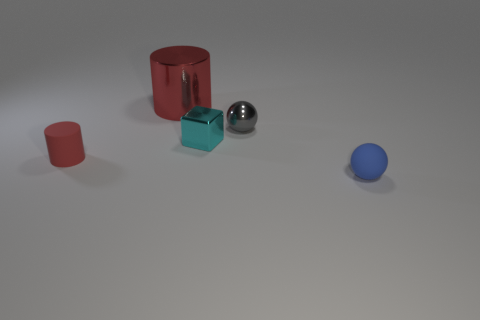What number of objects are both behind the small cylinder and right of the red shiny cylinder?
Your response must be concise. 2. Are there any other things that have the same size as the blue ball?
Your answer should be compact. Yes. Are there more small metallic objects right of the small blue matte ball than small blue balls behind the big red cylinder?
Your answer should be very brief. No. What material is the tiny ball on the right side of the tiny shiny ball?
Offer a terse response. Rubber. Is the shape of the red metal thing the same as the rubber thing that is to the right of the red shiny cylinder?
Your response must be concise. No. What number of red cylinders are in front of the rubber thing right of the ball left of the rubber sphere?
Your answer should be very brief. 0. What color is the other rubber object that is the same shape as the big red thing?
Make the answer very short. Red. Is there any other thing that is the same shape as the cyan thing?
Provide a short and direct response. No. What number of blocks are tiny cyan metal things or large objects?
Make the answer very short. 1. What is the shape of the cyan metal object?
Offer a terse response. Cube. 